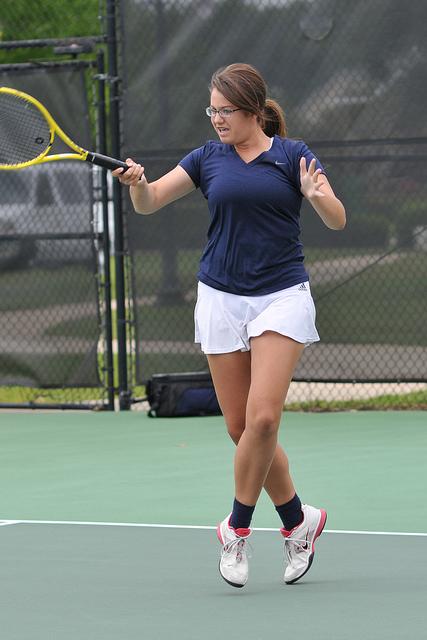Is the woman a professional tennis player?
Write a very short answer. No. Is she wearing a hat?
Answer briefly. No. What color are her shorts?
Write a very short answer. White. What is in the young girls hand?
Be succinct. Racket. What color is the girl's shirt?
Answer briefly. Blue. Has she played this game before?
Keep it brief. Yes. Is she playing for a college team?
Write a very short answer. No. What color is the woman's skirt?
Concise answer only. White. Is the girl playing tennis?
Concise answer only. Yes. 